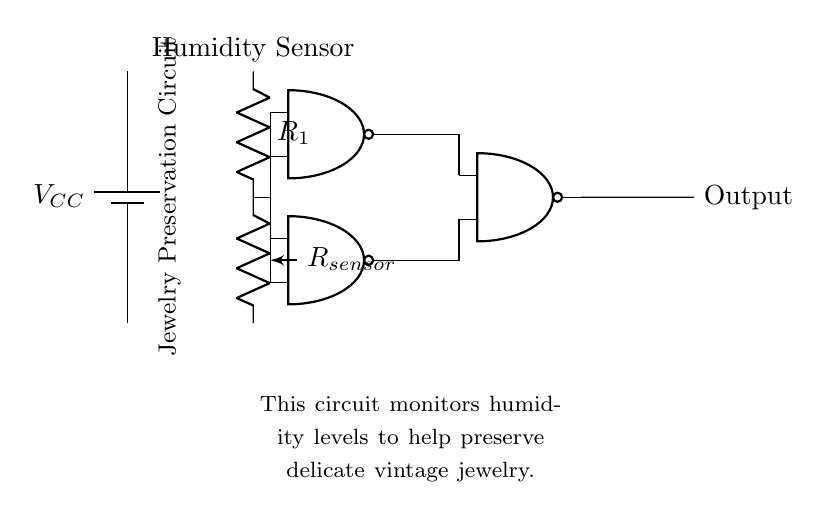What component is used to sense humidity? The circuit diagram includes a humidity sensor labeled as "R_sensor," which is responsible for monitoring moisture levels.
Answer: R_sensor How many NAND gates are present in the circuit? The diagram shows three NAND gates designated as nand1, nand2, and nand3. Therefore, the count of NAND gates is three.
Answer: 3 What is the function of the NAND gates in this circuit? The NAND gates process the signals received from the humidity sensor and control the output based on the logical conditions. In this context, they ensure the output corresponds to the humidity level regulated for jewelry preservation.
Answer: Logic control What is the purpose of this circuit? The primary function of the circuit is to monitor humidity levels to help preserve delicate vintage jewelry, as explicitly noted in the explanatory text below the diagram.
Answer: Jewelry preservation Which component is the power supply in the circuit? The power supply is represented by a battery labeled "V_CC," providing the necessary voltage for the circuit's operation.
Answer: V_CC What type of logic gate is used in this circuit diagram? The circuit employs NAND gates, which are a specific type of digital logic gate that outputs false only when all inputs are true, serving the needs of the circuit in preserving jewelry during humidity fluctuations.
Answer: NAND 